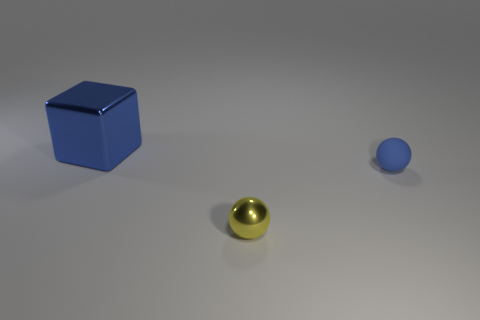Add 3 cubes. How many objects exist? 6 Subtract all blocks. How many objects are left? 2 Add 3 small blue things. How many small blue things are left? 4 Add 2 small yellow shiny spheres. How many small yellow shiny spheres exist? 3 Subtract 1 blue spheres. How many objects are left? 2 Subtract all small yellow cylinders. Subtract all large blue cubes. How many objects are left? 2 